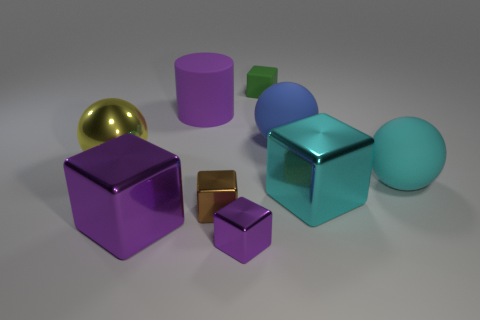Is the size of the metallic cube that is to the right of the tiny purple metal block the same as the rubber sphere in front of the blue rubber object?
Ensure brevity in your answer.  Yes. What color is the shiny object that is the same shape as the big cyan rubber thing?
Provide a short and direct response. Yellow. Is there anything else that has the same shape as the blue thing?
Provide a short and direct response. Yes. Is the number of blue rubber balls that are behind the green matte block greater than the number of tiny cubes on the left side of the big purple shiny cube?
Your answer should be compact. No. There is a purple cylinder that is left of the big cube to the right of the thing behind the big purple rubber thing; what size is it?
Your response must be concise. Large. Do the cylinder and the big ball left of the small green matte object have the same material?
Ensure brevity in your answer.  No. Do the purple matte object and the blue matte thing have the same shape?
Provide a succinct answer. No. How many other objects are there of the same material as the green block?
Make the answer very short. 3. What number of other brown shiny objects have the same shape as the small brown shiny object?
Your response must be concise. 0. What is the color of the big object that is in front of the large cyan rubber sphere and to the left of the green block?
Give a very brief answer. Purple. 